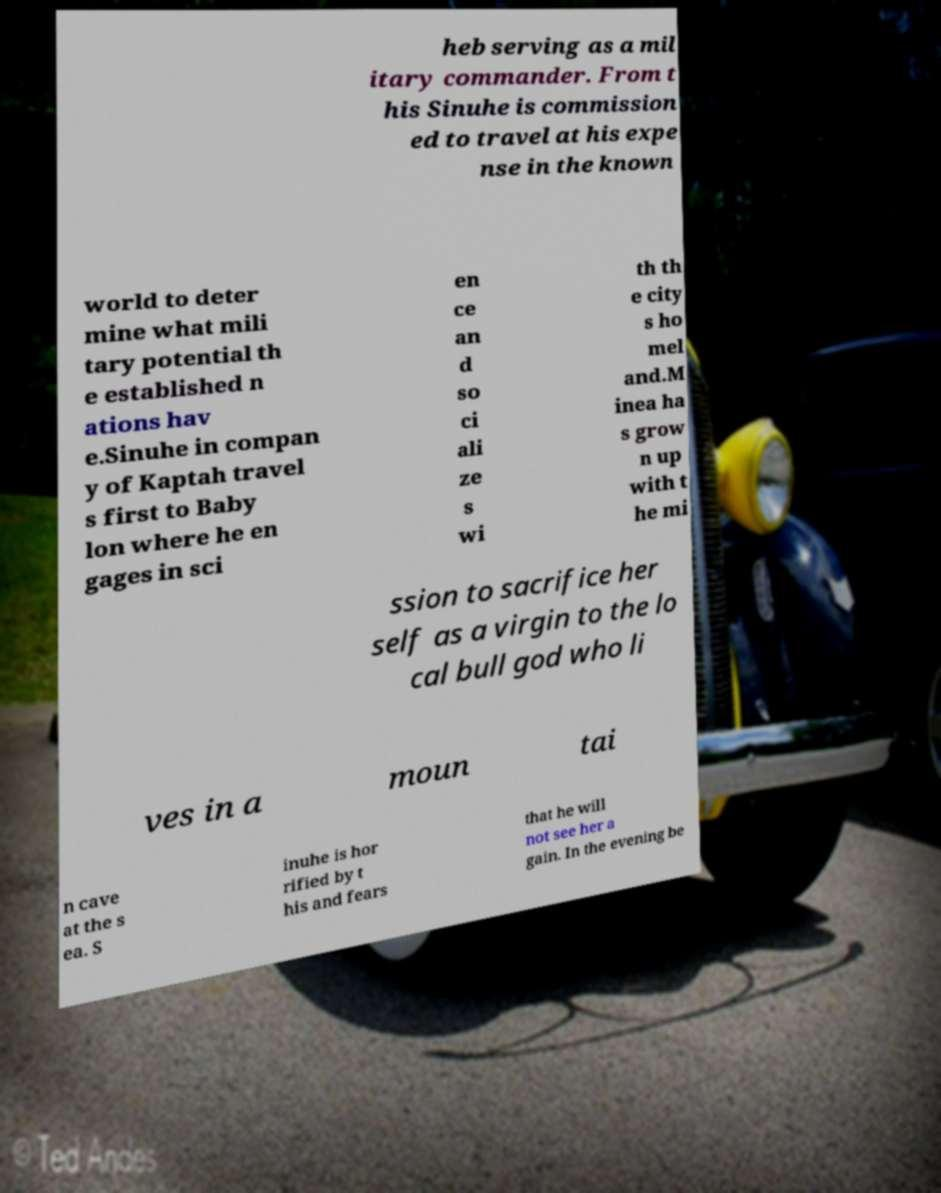Can you accurately transcribe the text from the provided image for me? heb serving as a mil itary commander. From t his Sinuhe is commission ed to travel at his expe nse in the known world to deter mine what mili tary potential th e established n ations hav e.Sinuhe in compan y of Kaptah travel s first to Baby lon where he en gages in sci en ce an d so ci ali ze s wi th th e city s ho mel and.M inea ha s grow n up with t he mi ssion to sacrifice her self as a virgin to the lo cal bull god who li ves in a moun tai n cave at the s ea. S inuhe is hor rified by t his and fears that he will not see her a gain. In the evening be 